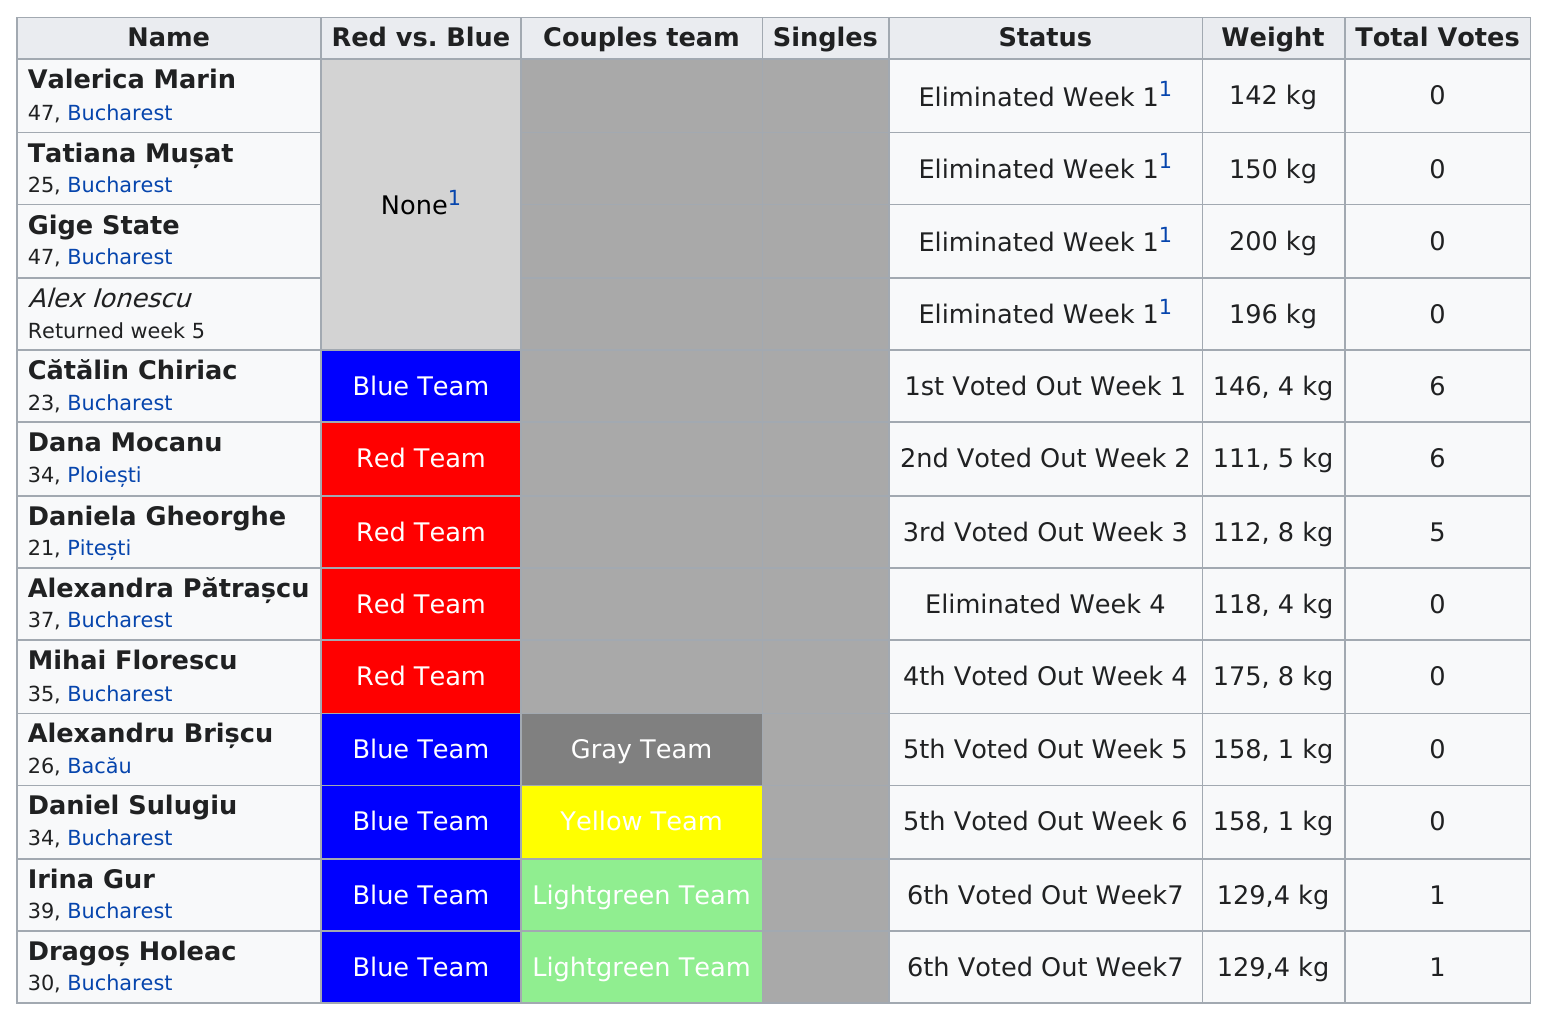Highlight a few significant elements in this photo. Four contestants were eliminated in the first week of the competition. Tatiana Musat and Valencia Marian were eliminated, and there was a difference of 8 kg between their weights at that time. In week 1, a total of 4 people were eliminated. The average weight of the first three contestants is 164 kg. Cătălin Chiriac had a higher weight than Mocanu. 